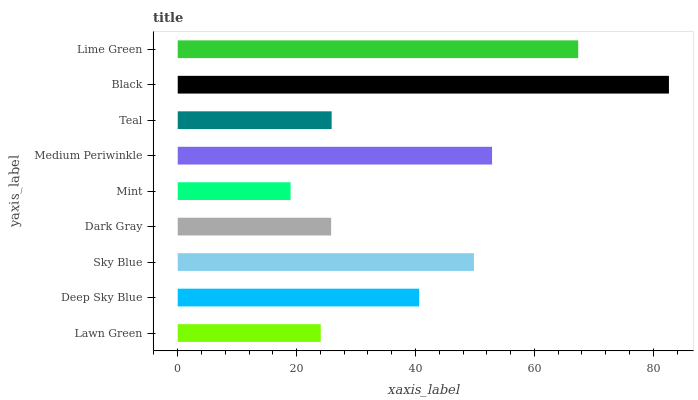Is Mint the minimum?
Answer yes or no. Yes. Is Black the maximum?
Answer yes or no. Yes. Is Deep Sky Blue the minimum?
Answer yes or no. No. Is Deep Sky Blue the maximum?
Answer yes or no. No. Is Deep Sky Blue greater than Lawn Green?
Answer yes or no. Yes. Is Lawn Green less than Deep Sky Blue?
Answer yes or no. Yes. Is Lawn Green greater than Deep Sky Blue?
Answer yes or no. No. Is Deep Sky Blue less than Lawn Green?
Answer yes or no. No. Is Deep Sky Blue the high median?
Answer yes or no. Yes. Is Deep Sky Blue the low median?
Answer yes or no. Yes. Is Teal the high median?
Answer yes or no. No. Is Black the low median?
Answer yes or no. No. 